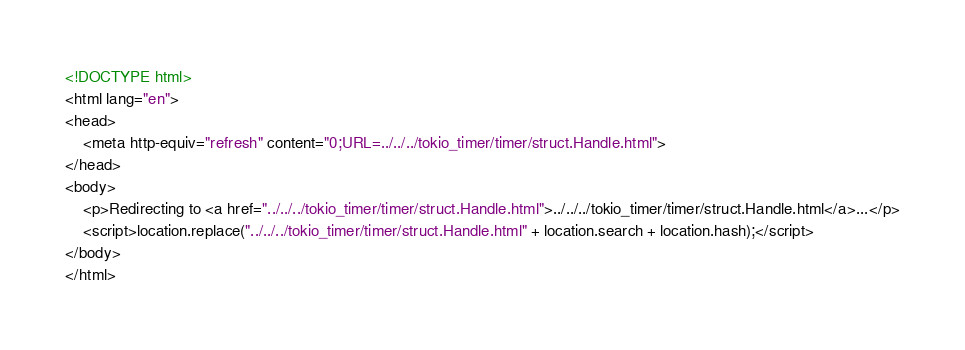Convert code to text. <code><loc_0><loc_0><loc_500><loc_500><_HTML_><!DOCTYPE html>
<html lang="en">
<head>
    <meta http-equiv="refresh" content="0;URL=../../../tokio_timer/timer/struct.Handle.html">
</head>
<body>
    <p>Redirecting to <a href="../../../tokio_timer/timer/struct.Handle.html">../../../tokio_timer/timer/struct.Handle.html</a>...</p>
    <script>location.replace("../../../tokio_timer/timer/struct.Handle.html" + location.search + location.hash);</script>
</body>
</html></code> 